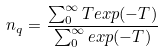Convert formula to latex. <formula><loc_0><loc_0><loc_500><loc_500>n _ { q } = \frac { \sum _ { 0 } ^ { \infty } T e x p ( - T ) } { \sum _ { 0 } ^ { \infty } e x p ( - T ) }</formula> 